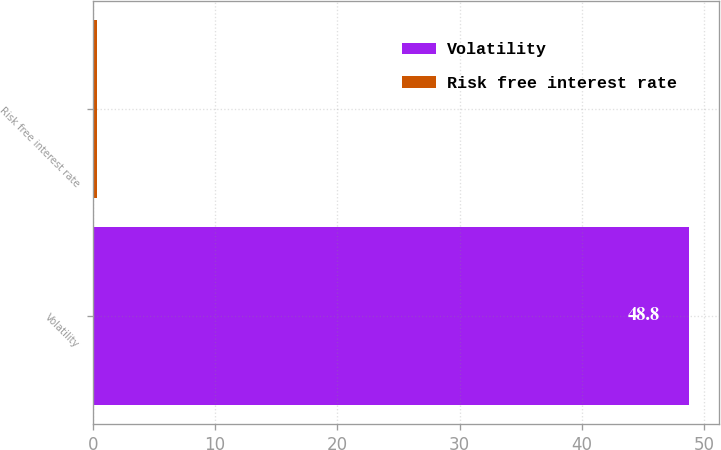<chart> <loc_0><loc_0><loc_500><loc_500><bar_chart><fcel>Volatility<fcel>Risk free interest rate<nl><fcel>48.8<fcel>0.32<nl></chart> 